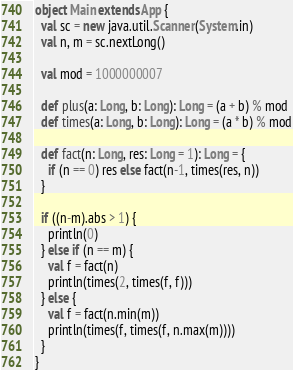<code> <loc_0><loc_0><loc_500><loc_500><_Scala_>object Main extends App {
  val sc = new java.util.Scanner(System.in)
  val n, m = sc.nextLong()

  val mod = 1000000007

  def plus(a: Long, b: Long): Long = (a + b) % mod
  def times(a: Long, b: Long): Long = (a * b) % mod

  def fact(n: Long, res: Long = 1): Long = {
    if (n == 0) res else fact(n-1, times(res, n))
  }

  if ((n-m).abs > 1) {
    println(0)
  } else if (n == m) {
    val f = fact(n)
    println(times(2, times(f, f)))
  } else {
    val f = fact(n.min(m))
    println(times(f, times(f, n.max(m))))
  }
}
</code> 